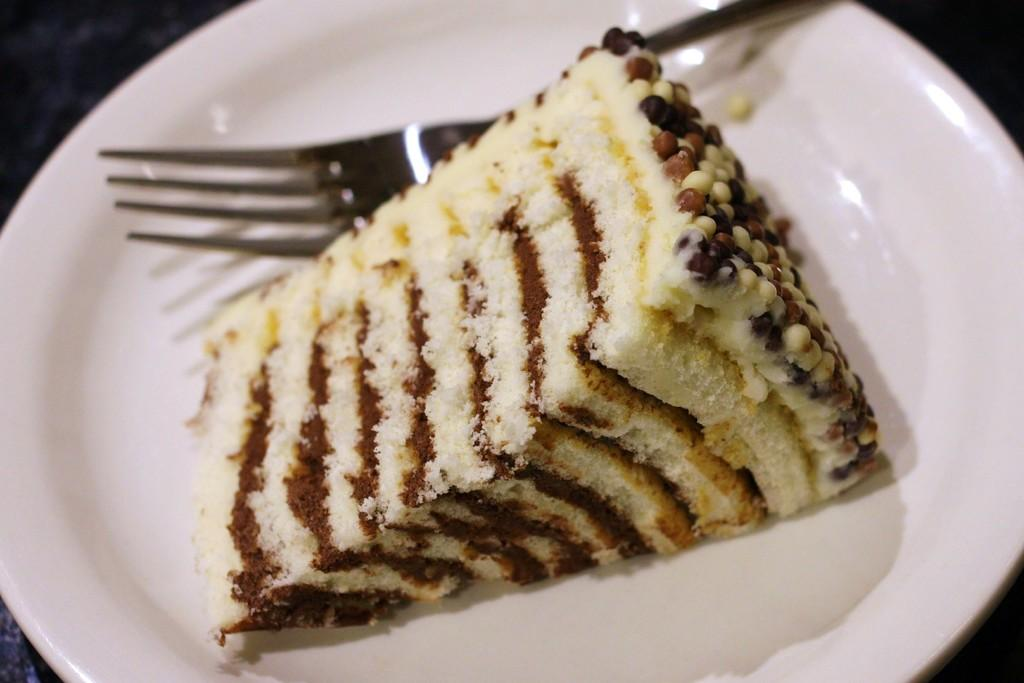What is the main food item in the image? There is a piece of cake in the image. How is the cake presented in the image? The cake is placed on a plate. What utensil is visible in the image? There is a fork in the image. What type of leaf is used as a decoration on the cake in the image? There is no leaf present on the cake in the image. Can you tell me how the rat is interacting with the fork in the image? There is no rat present in the image. 